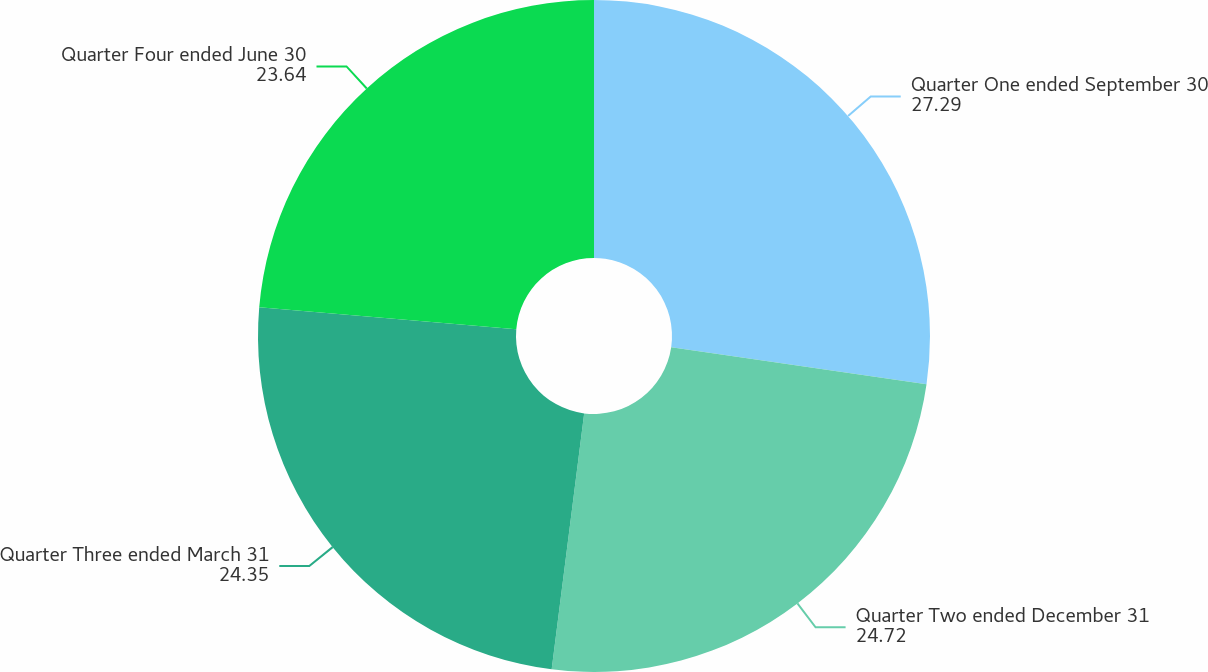Convert chart to OTSL. <chart><loc_0><loc_0><loc_500><loc_500><pie_chart><fcel>Quarter One ended September 30<fcel>Quarter Two ended December 31<fcel>Quarter Three ended March 31<fcel>Quarter Four ended June 30<nl><fcel>27.29%<fcel>24.72%<fcel>24.35%<fcel>23.64%<nl></chart> 